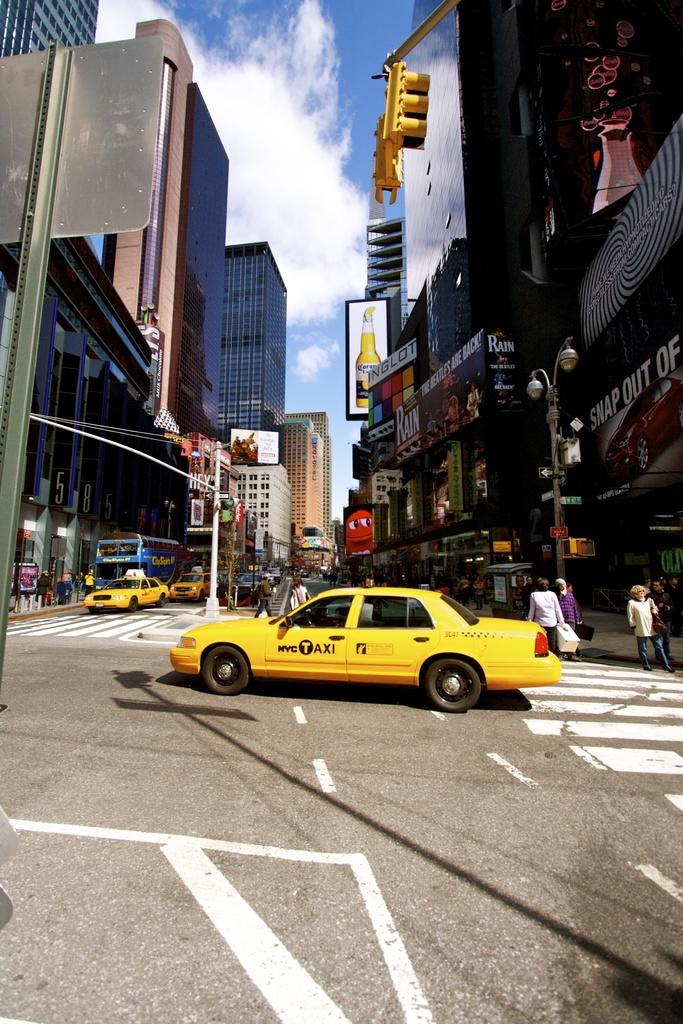<image>
Describe the image concisely. A street scene with a yellow vehicle with Taxi on the door. 